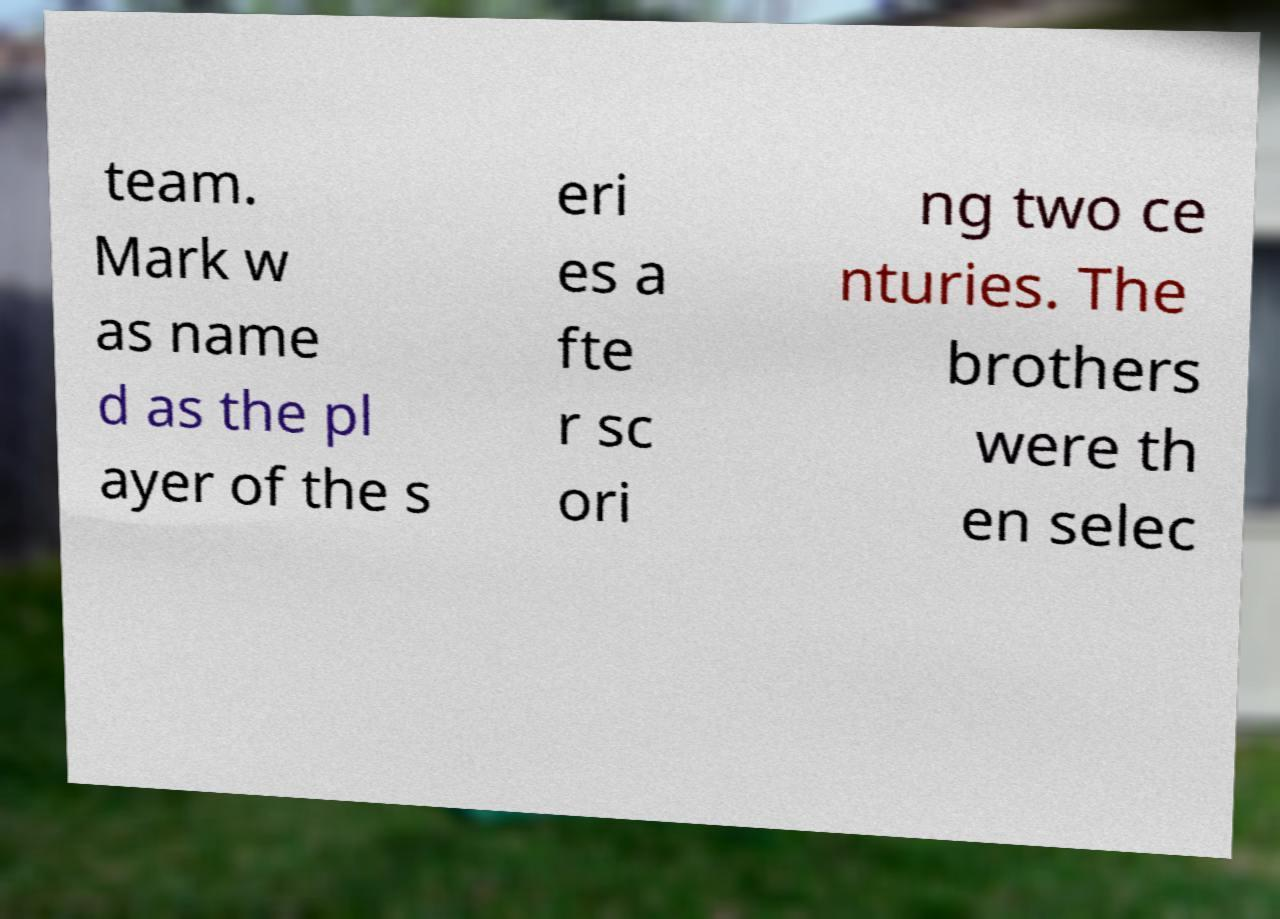Could you assist in decoding the text presented in this image and type it out clearly? team. Mark w as name d as the pl ayer of the s eri es a fte r sc ori ng two ce nturies. The brothers were th en selec 